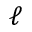Convert formula to latex. <formula><loc_0><loc_0><loc_500><loc_500>\ell</formula> 